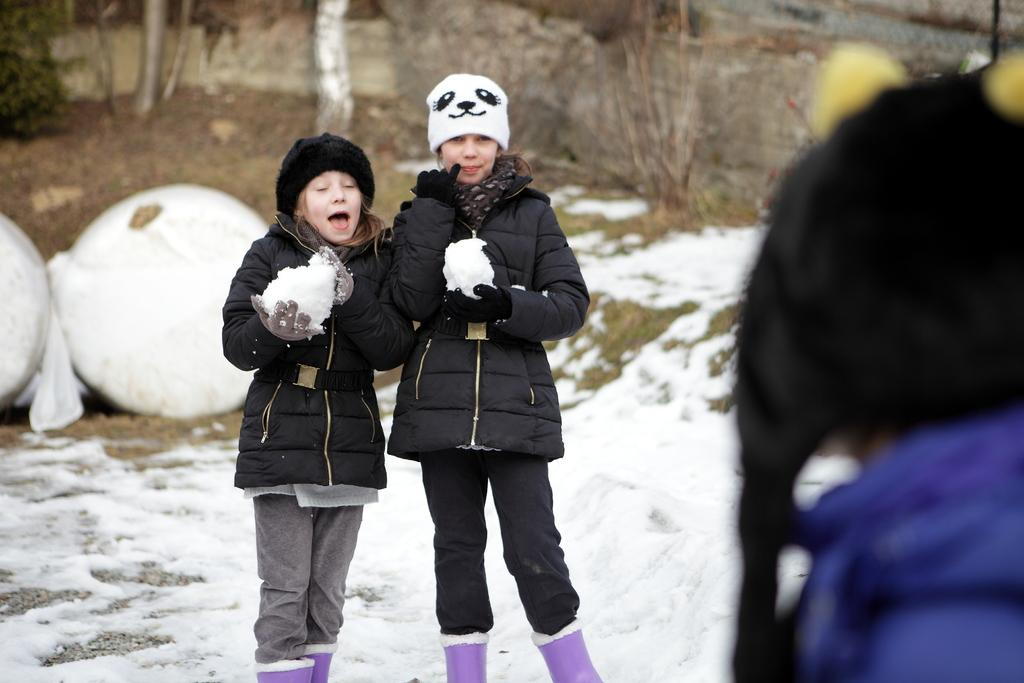How many people are in the image? There are three people in the image. What are two of the people doing in the image? Two of the people are standing. What are the standing people holding in the image? The standing people are holding snow. What is on the ground in the image? There is snow on the ground. What can be seen in the background of the image? There are trees in the background of the image. What type of drug can be seen in the image? There is no drug present in the image; it features three people standing and holding snow. What is the view like from the toes of the standing people in the image? The image does not show the toes of the standing people, so it is not possible to describe the view from that perspective. 